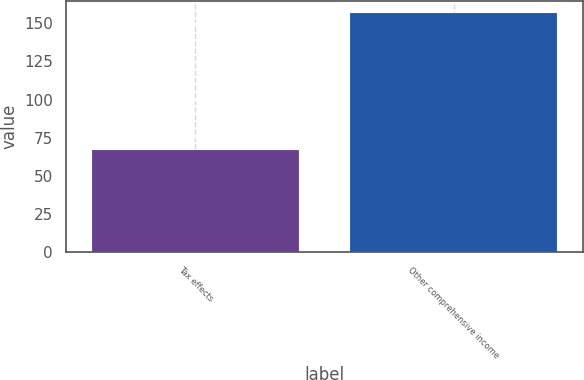<chart> <loc_0><loc_0><loc_500><loc_500><bar_chart><fcel>Tax effects<fcel>Other comprehensive income<nl><fcel>67<fcel>157<nl></chart> 